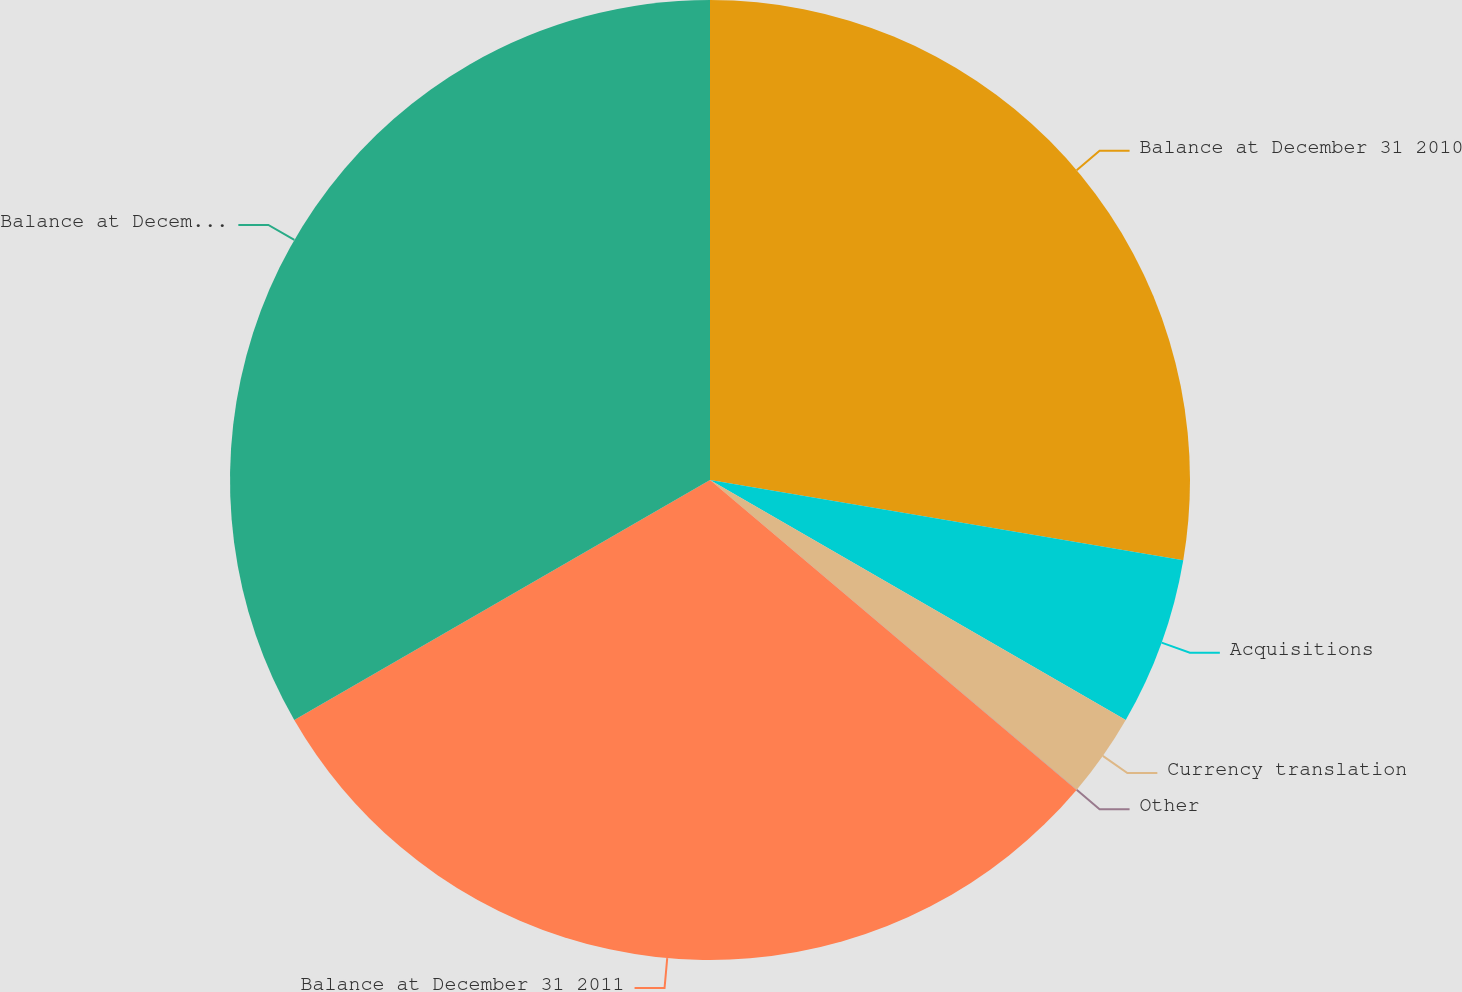<chart> <loc_0><loc_0><loc_500><loc_500><pie_chart><fcel>Balance at December 31 2010<fcel>Acquisitions<fcel>Currency translation<fcel>Other<fcel>Balance at December 31 2011<fcel>Balance at December 31 2012<nl><fcel>27.67%<fcel>5.66%<fcel>2.83%<fcel>0.01%<fcel>30.5%<fcel>33.33%<nl></chart> 